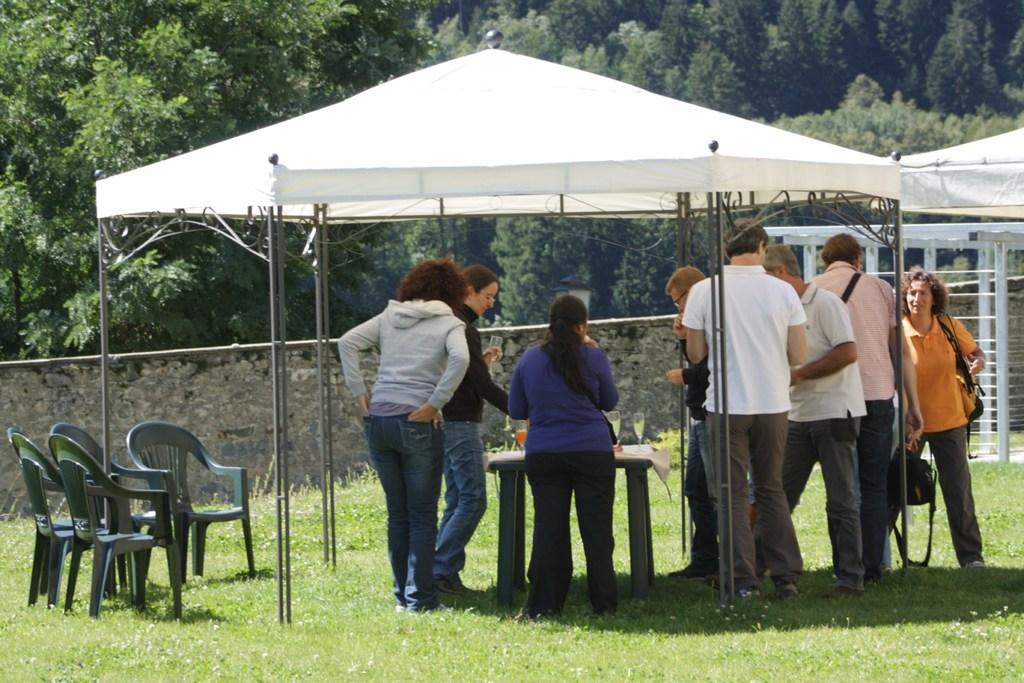How many people are in the image? There is a group of people in the image, but the exact number is not specified. Where are the people located in the image? The people are standing under a tent in the image. What is in front of the people? There is a table in front of the people. What type of furniture is visible at the bottom left side of the image? There are chairs at the bottom left side of the image. What can be seen behind the people? Trees are visible behind the people. What type of map is being used by the people in the image? There is no map present in the image; the people are standing under a tent. What facial expressions can be seen on the people's faces in the image? The image does not show the people's faces, so their expressions cannot be determined. 